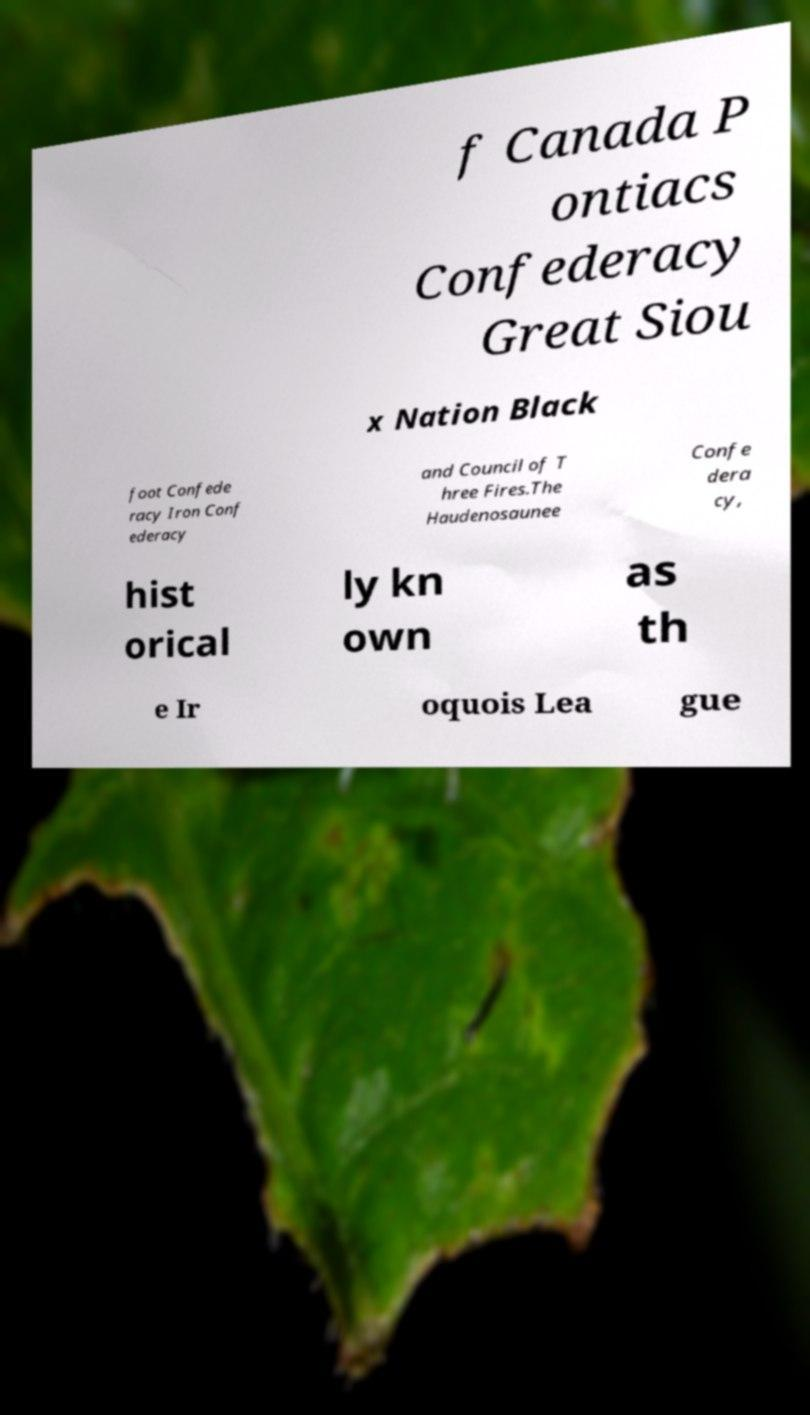Please identify and transcribe the text found in this image. f Canada P ontiacs Confederacy Great Siou x Nation Black foot Confede racy Iron Conf ederacy and Council of T hree Fires.The Haudenosaunee Confe dera cy, hist orical ly kn own as th e Ir oquois Lea gue 